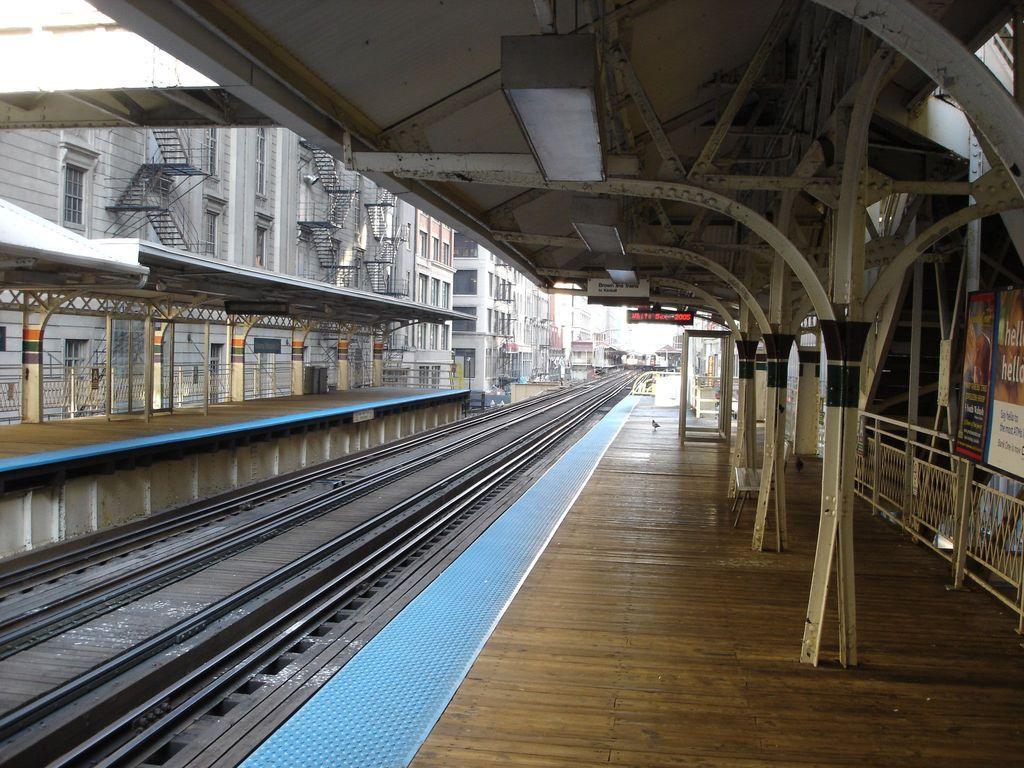Can you describe this image briefly? In this image I can see the platform, tracks, few banners, boards. In the background I can see few buildings and the sky is in white color. 